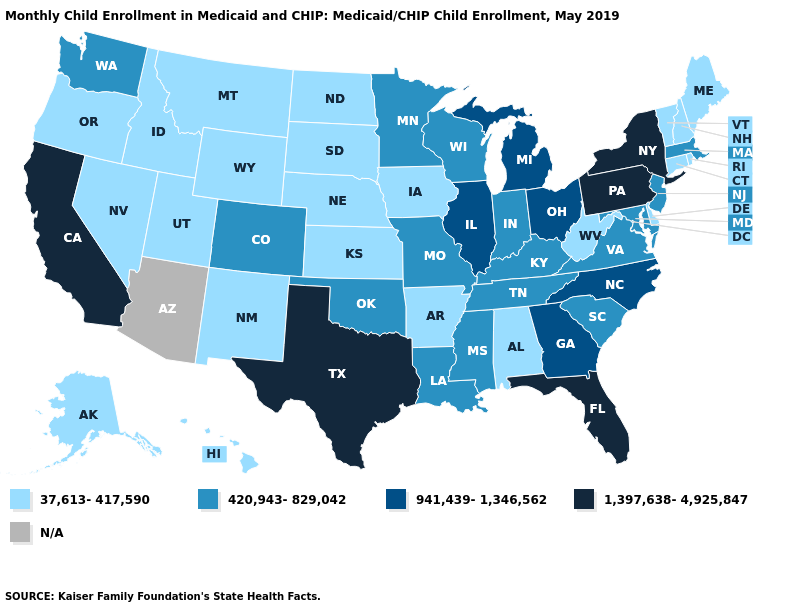Name the states that have a value in the range N/A?
Give a very brief answer. Arizona. What is the value of Iowa?
Give a very brief answer. 37,613-417,590. What is the value of Minnesota?
Keep it brief. 420,943-829,042. Is the legend a continuous bar?
Quick response, please. No. What is the value of Maine?
Short answer required. 37,613-417,590. Name the states that have a value in the range N/A?
Concise answer only. Arizona. Name the states that have a value in the range 37,613-417,590?
Write a very short answer. Alabama, Alaska, Arkansas, Connecticut, Delaware, Hawaii, Idaho, Iowa, Kansas, Maine, Montana, Nebraska, Nevada, New Hampshire, New Mexico, North Dakota, Oregon, Rhode Island, South Dakota, Utah, Vermont, West Virginia, Wyoming. What is the highest value in the MidWest ?
Give a very brief answer. 941,439-1,346,562. What is the value of Nevada?
Keep it brief. 37,613-417,590. Does Minnesota have the lowest value in the USA?
Answer briefly. No. What is the value of Oklahoma?
Quick response, please. 420,943-829,042. What is the lowest value in the USA?
Keep it brief. 37,613-417,590. Which states have the highest value in the USA?
Give a very brief answer. California, Florida, New York, Pennsylvania, Texas. What is the highest value in the South ?
Quick response, please. 1,397,638-4,925,847. 